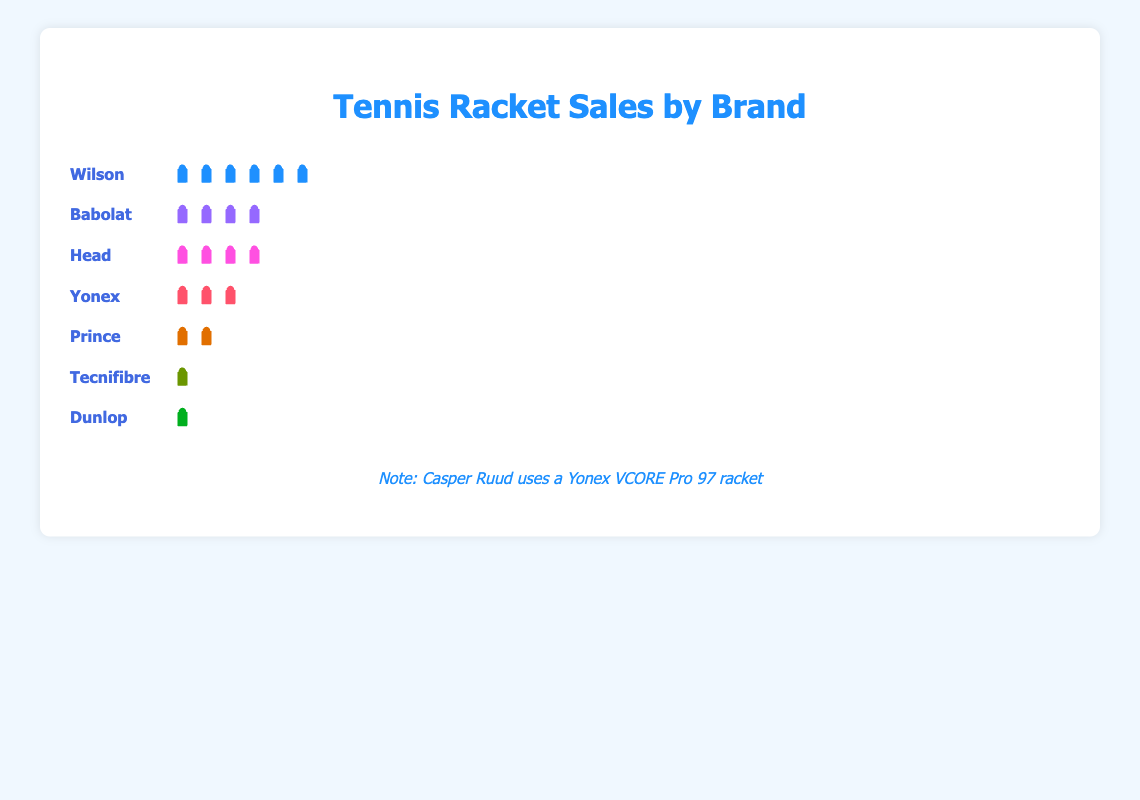What's the title of the figure? The title is displayed at the top center of the plot. It reads "Tennis Racket Sales by Brand."
Answer: Tennis Racket Sales by Brand How many Wilson rackets were sold compared to Babolat rackets? Wilson has 280 rackets and Babolat has 220 rackets. The difference is calculated by subtracting Babolat's count from Wilson's count (280 - 220).
Answer: 60 Which brand has the least number of rackets sold? The brand with the smallest icon line in the plot has the least sales. In this case, Dunlop has the shortest line, representing the smallest count of 30 rackets.
Answer: Dunlop What is the combined total of Head and Yonex rackets sold? Head sold 180 and Yonex sold 150 rackets. Adding these together gives 180 + 150.
Answer: 330 What percentage of the total sales does the Yonex brand represent? Yonex sold 150 rackets out of a total of 1000. To find the percentage, divide 150 by 1000 and multiply by 100 (150/1000 * 100).
Answer: 15% What is the difference in racket sales between the top manufacturer and the second-place manufacturer? Wilson is the top with 280 rackets, and Babolat is second with 220 rackets. The difference is 280 - 220.
Answer: 60 Which brands have fewer than 100 rackets sold? Observing the plot, the brands with fewer than 100 icons are Prince (90), Tecnifibre (50), and Dunlop (30).
Answer: Prince, Tecnifibre, Dunlop If Casper Ruud's favorite racket is a Yonex, where does Yonex rank in terms of sales among all brands listed? Yonex is ranked by counting its position based on the number of sales, with Wilson, Babolat, and Head preceding it, placing Yonex at fourth.
Answer: Fourth 